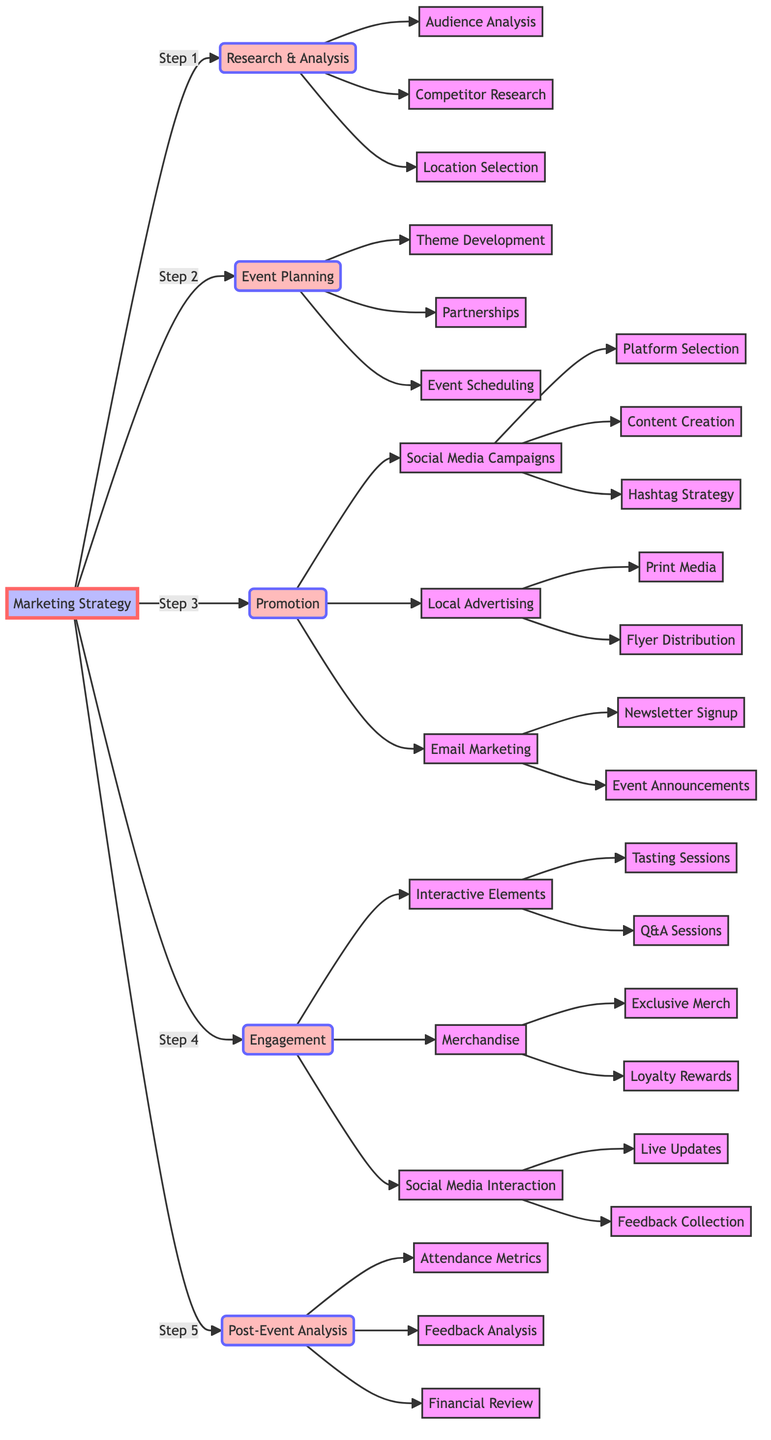What are the five main categories in the marketing strategy? The diagram indicates five main categories branching from the "Marketing Strategy" node: Research & Analysis, Event Planning, Promotion, Engagement, and Post-Event Analysis.
Answer: Research & Analysis, Event Planning, Promotion, Engagement, Post-Event Analysis How many subcategories are under Promotion? The Promotion node breaks down into three subcategories: Social Media Campaigns, Local Advertising, and Email Marketing. Counting these gives us three subcategories.
Answer: 3 Which category includes Q&A sessions? The Q&A sessions are listed under the Engagement category, specifically as part of the Interactive Elements node.
Answer: Engagement What is the first step in the marketing strategy? According to the flowchart, the first step indicated is Research & Analysis, which is the first node connected to the Marketing Strategy node.
Answer: Research & Analysis How many nodes are under Social Media Campaigns? The Social Media Campaigns node has three connected nodes: Platform Selection, Content Creation, and Hashtag Strategy. This makes a total of three nodes under Social Media Campaigns.
Answer: 3 What are the two elements involved in Interactive Elements? The Interactive Elements node splits into two components: Tasting Sessions and Q&A Sessions. Together, these define the main elements of this category.
Answer: Tasting Sessions, Q&A Sessions What type of advertising is included under Local Advertising? The Local Advertising category consists of two types: Print Media and Flyer Distribution. These two represent the forms of advertising indicated.
Answer: Print Media, Flyer Distribution What is analyzed in the Post-Event Analysis category? Under Post-Event Analysis, three aspects are analyzed: Attendance Metrics, Feedback Analysis, and Financial Review. These aspects measure the event's success.
Answer: Attendance Metrics, Feedback Analysis, Financial Review How does the flowchart visually represent relationships? The flowchart uses arrows to indicate relationships or connections between different categories and nodes, showing the hierarchical structure of the marketing strategy.
Answer: Arrows 